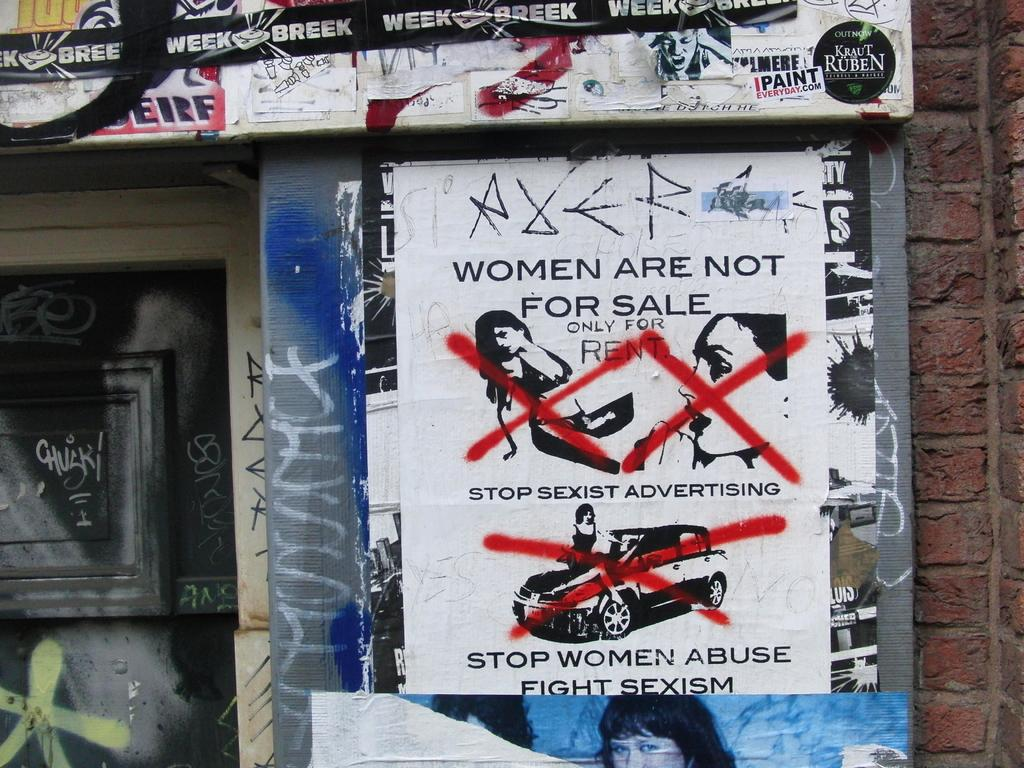What is on the wall in the image? There are posters on the wall in the image. What can be found on the posters? The posters contain text. What is located on the left side of the image? There is a black color door on the left side of the image. Can you see a glove hanging from the door in the image? There is no glove present in the image. Is there a hole in the wall where the posters are located? There is no hole in the wall where the posters are located; the wall appears to be intact. 